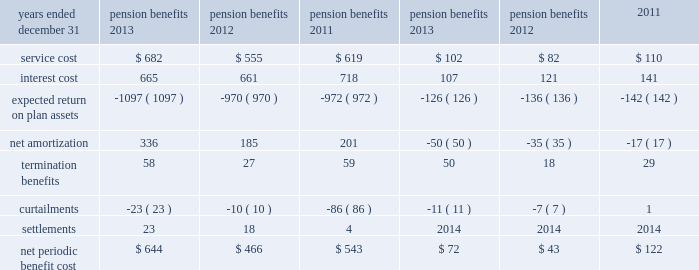13 .
Pension and other postretirement benefit plans the company has defined benefit pension plans covering eligible employees in the united states and in certain of its international subsidiaries .
As a result of plan design changes approved in 2011 , beginning on january 1 , 2013 , active participants in merck 2019s primary u.s .
Defined benefit pension plans are accruing pension benefits using new cash balance formulas based on age , service , pay and interest .
However , during a transition period from january 1 , 2013 through december 31 , 2019 , participants will earn the greater of the benefit as calculated under the employee 2019s legacy final average pay formula or their new cash balance formula .
For all years of service after december 31 , 2019 , participants will earn future benefits under only the cash balance formula .
In addition , the company provides medical benefits , principally to its eligible u.s .
Retirees and their dependents , through its other postretirement benefit plans .
The company uses december 31 as the year-end measurement date for all of its pension plans and other postretirement benefit plans .
Net periodic benefit cost the net periodic benefit cost for pension and other postretirement benefit plans consisted of the following components: .
The increase in net periodic benefit cost for pension and other postretirement benefit plans in 2013 as compared with 2012 is largely attributable to a change in the discount rate .
The net periodic benefit cost attributable to u.s .
Pension plans included in the above table was $ 348 million in 2013 , $ 268 million in 2012 and $ 406 million in in connection with restructuring actions ( see note 3 ) , termination charges were recorded in 2013 , 2012 and 2011 on pension and other postretirement benefit plans related to expanded eligibility for certain employees exiting merck .
Also , in connection with these restructuring activities , curtailments were recorded in 2013 , 2012 and 2011 on pension and other postretirement benefit plans .
In addition , settlements were recorded in 2013 , 2012 and 2011 on certain domestic and international pension plans .
Table of contents .
Considering the years 2013 and 2012 , what is the variation observed in the expected return on plan assets , in millions? 
Rationale: it is the difference between each year's expected return on plan assets .
Computations: (1097 - 970)
Answer: 127.0. 13 .
Pension and other postretirement benefit plans the company has defined benefit pension plans covering eligible employees in the united states and in certain of its international subsidiaries .
As a result of plan design changes approved in 2011 , beginning on january 1 , 2013 , active participants in merck 2019s primary u.s .
Defined benefit pension plans are accruing pension benefits using new cash balance formulas based on age , service , pay and interest .
However , during a transition period from january 1 , 2013 through december 31 , 2019 , participants will earn the greater of the benefit as calculated under the employee 2019s legacy final average pay formula or their new cash balance formula .
For all years of service after december 31 , 2019 , participants will earn future benefits under only the cash balance formula .
In addition , the company provides medical benefits , principally to its eligible u.s .
Retirees and their dependents , through its other postretirement benefit plans .
The company uses december 31 as the year-end measurement date for all of its pension plans and other postretirement benefit plans .
Net periodic benefit cost the net periodic benefit cost for pension and other postretirement benefit plans consisted of the following components: .
The increase in net periodic benefit cost for pension and other postretirement benefit plans in 2013 as compared with 2012 is largely attributable to a change in the discount rate .
The net periodic benefit cost attributable to u.s .
Pension plans included in the above table was $ 348 million in 2013 , $ 268 million in 2012 and $ 406 million in in connection with restructuring actions ( see note 3 ) , termination charges were recorded in 2013 , 2012 and 2011 on pension and other postretirement benefit plans related to expanded eligibility for certain employees exiting merck .
Also , in connection with these restructuring activities , curtailments were recorded in 2013 , 2012 and 2011 on pension and other postretirement benefit plans .
In addition , settlements were recorded in 2013 , 2012 and 2011 on certain domestic and international pension plans .
Table of contents .
In 2013 what was the percent of the net periodic benefit cost attributable to the us? 
Rationale: in 2013 72.4% of the net periodic benefit cost was attributable to the us
Computations: (466 / 644)
Answer: 0.7236. 13 .
Pension and other postretirement benefit plans the company has defined benefit pension plans covering eligible employees in the united states and in certain of its international subsidiaries .
As a result of plan design changes approved in 2011 , beginning on january 1 , 2013 , active participants in merck 2019s primary u.s .
Defined benefit pension plans are accruing pension benefits using new cash balance formulas based on age , service , pay and interest .
However , during a transition period from january 1 , 2013 through december 31 , 2019 , participants will earn the greater of the benefit as calculated under the employee 2019s legacy final average pay formula or their new cash balance formula .
For all years of service after december 31 , 2019 , participants will earn future benefits under only the cash balance formula .
In addition , the company provides medical benefits , principally to its eligible u.s .
Retirees and their dependents , through its other postretirement benefit plans .
The company uses december 31 as the year-end measurement date for all of its pension plans and other postretirement benefit plans .
Net periodic benefit cost the net periodic benefit cost for pension and other postretirement benefit plans consisted of the following components: .
The increase in net periodic benefit cost for pension and other postretirement benefit plans in 2013 as compared with 2012 is largely attributable to a change in the discount rate .
The net periodic benefit cost attributable to u.s .
Pension plans included in the above table was $ 348 million in 2013 , $ 268 million in 2012 and $ 406 million in in connection with restructuring actions ( see note 3 ) , termination charges were recorded in 2013 , 2012 and 2011 on pension and other postretirement benefit plans related to expanded eligibility for certain employees exiting merck .
Also , in connection with these restructuring activities , curtailments were recorded in 2013 , 2012 and 2011 on pension and other postretirement benefit plans .
In addition , settlements were recorded in 2013 , 2012 and 2011 on certain domestic and international pension plans .
Table of contents .
Considering the years 2012 and 2013 , what is the increase observed in the service cost? 
Rationale: it is the value of service cost in 2013 divided by the 2012's , then turned into a percentage to represent the increase .
Computations: ((682 / 555) - 1)
Answer: 0.22883. 